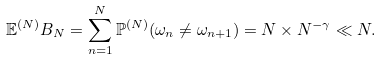Convert formula to latex. <formula><loc_0><loc_0><loc_500><loc_500>\mathbb { E } ^ { ( N ) } B _ { N } = \sum _ { n = 1 } ^ { N } \mathbb { P } ^ { ( N ) } ( \omega _ { n } \neq \omega _ { n + 1 } ) = N \times N ^ { - \gamma } \ll N .</formula> 